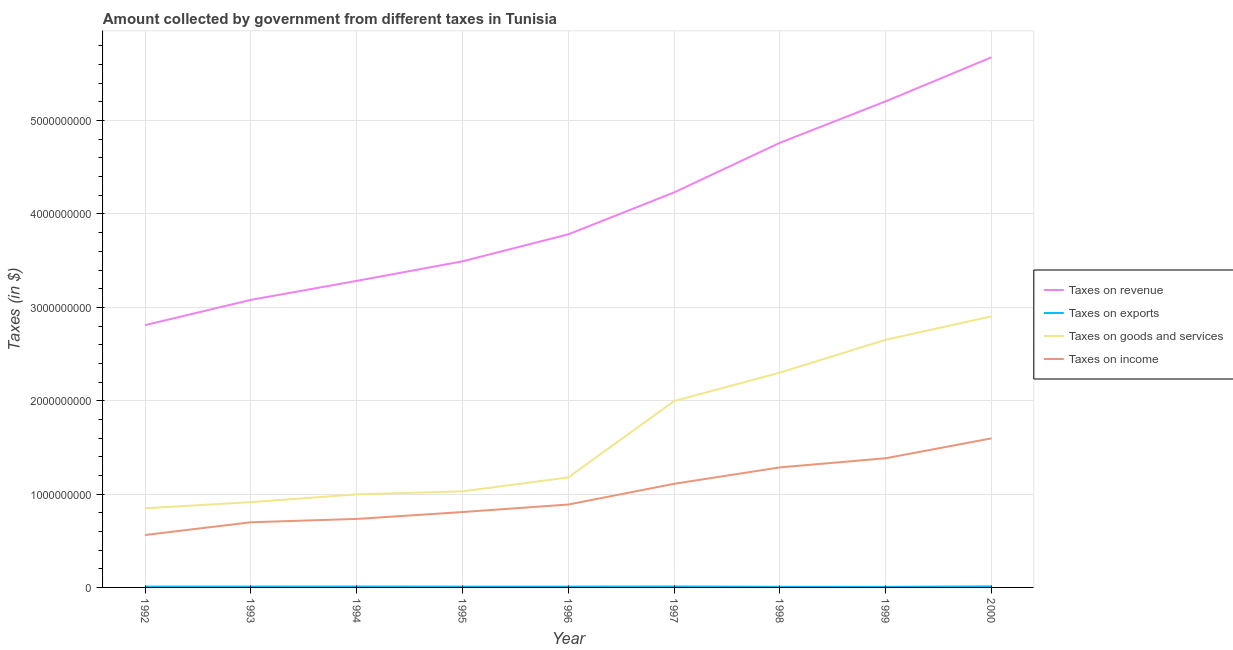Does the line corresponding to amount collected as tax on income intersect with the line corresponding to amount collected as tax on goods?
Your answer should be compact. No. What is the amount collected as tax on goods in 2000?
Your answer should be very brief. 2.90e+09. Across all years, what is the maximum amount collected as tax on income?
Provide a short and direct response. 1.60e+09. Across all years, what is the minimum amount collected as tax on exports?
Offer a very short reply. 6.20e+06. What is the total amount collected as tax on goods in the graph?
Give a very brief answer. 1.48e+1. What is the difference between the amount collected as tax on exports in 1995 and that in 2000?
Your answer should be very brief. -2.60e+06. What is the difference between the amount collected as tax on income in 1992 and the amount collected as tax on revenue in 1998?
Your response must be concise. -4.20e+09. What is the average amount collected as tax on exports per year?
Offer a terse response. 8.81e+06. In the year 1999, what is the difference between the amount collected as tax on exports and amount collected as tax on income?
Give a very brief answer. -1.38e+09. What is the ratio of the amount collected as tax on goods in 1993 to that in 1997?
Your response must be concise. 0.46. Is the difference between the amount collected as tax on revenue in 1992 and 1999 greater than the difference between the amount collected as tax on goods in 1992 and 1999?
Offer a terse response. No. What is the difference between the highest and the second highest amount collected as tax on goods?
Your answer should be very brief. 2.51e+08. What is the difference between the highest and the lowest amount collected as tax on income?
Ensure brevity in your answer.  1.04e+09. In how many years, is the amount collected as tax on revenue greater than the average amount collected as tax on revenue taken over all years?
Keep it short and to the point. 4. Is the sum of the amount collected as tax on revenue in 1992 and 1997 greater than the maximum amount collected as tax on income across all years?
Make the answer very short. Yes. Is it the case that in every year, the sum of the amount collected as tax on exports and amount collected as tax on goods is greater than the sum of amount collected as tax on revenue and amount collected as tax on income?
Provide a succinct answer. No. Is it the case that in every year, the sum of the amount collected as tax on revenue and amount collected as tax on exports is greater than the amount collected as tax on goods?
Keep it short and to the point. Yes. Does the amount collected as tax on exports monotonically increase over the years?
Your response must be concise. No. Is the amount collected as tax on income strictly greater than the amount collected as tax on revenue over the years?
Your response must be concise. No. Is the amount collected as tax on revenue strictly less than the amount collected as tax on income over the years?
Give a very brief answer. No. How many lines are there?
Your answer should be compact. 4. How many years are there in the graph?
Ensure brevity in your answer.  9. What is the difference between two consecutive major ticks on the Y-axis?
Offer a terse response. 1.00e+09. Does the graph contain any zero values?
Your answer should be very brief. No. Does the graph contain grids?
Your response must be concise. Yes. Where does the legend appear in the graph?
Provide a short and direct response. Center right. How many legend labels are there?
Offer a very short reply. 4. How are the legend labels stacked?
Your response must be concise. Vertical. What is the title of the graph?
Provide a short and direct response. Amount collected by government from different taxes in Tunisia. Does "Insurance services" appear as one of the legend labels in the graph?
Offer a terse response. No. What is the label or title of the Y-axis?
Offer a terse response. Taxes (in $). What is the Taxes (in $) in Taxes on revenue in 1992?
Give a very brief answer. 2.81e+09. What is the Taxes (in $) in Taxes on exports in 1992?
Your answer should be compact. 9.10e+06. What is the Taxes (in $) in Taxes on goods and services in 1992?
Give a very brief answer. 8.48e+08. What is the Taxes (in $) of Taxes on income in 1992?
Make the answer very short. 5.62e+08. What is the Taxes (in $) in Taxes on revenue in 1993?
Ensure brevity in your answer.  3.08e+09. What is the Taxes (in $) in Taxes on exports in 1993?
Offer a terse response. 9.10e+06. What is the Taxes (in $) in Taxes on goods and services in 1993?
Offer a terse response. 9.14e+08. What is the Taxes (in $) in Taxes on income in 1993?
Offer a very short reply. 6.98e+08. What is the Taxes (in $) of Taxes on revenue in 1994?
Provide a short and direct response. 3.28e+09. What is the Taxes (in $) of Taxes on exports in 1994?
Provide a succinct answer. 9.70e+06. What is the Taxes (in $) of Taxes on goods and services in 1994?
Offer a very short reply. 9.97e+08. What is the Taxes (in $) of Taxes on income in 1994?
Your answer should be compact. 7.34e+08. What is the Taxes (in $) of Taxes on revenue in 1995?
Ensure brevity in your answer.  3.49e+09. What is the Taxes (in $) of Taxes on exports in 1995?
Your answer should be compact. 8.60e+06. What is the Taxes (in $) in Taxes on goods and services in 1995?
Your answer should be very brief. 1.03e+09. What is the Taxes (in $) of Taxes on income in 1995?
Make the answer very short. 8.07e+08. What is the Taxes (in $) of Taxes on revenue in 1996?
Offer a very short reply. 3.78e+09. What is the Taxes (in $) of Taxes on exports in 1996?
Provide a short and direct response. 8.50e+06. What is the Taxes (in $) of Taxes on goods and services in 1996?
Provide a succinct answer. 1.18e+09. What is the Taxes (in $) of Taxes on income in 1996?
Give a very brief answer. 8.88e+08. What is the Taxes (in $) of Taxes on revenue in 1997?
Make the answer very short. 4.23e+09. What is the Taxes (in $) of Taxes on exports in 1997?
Offer a terse response. 1.02e+07. What is the Taxes (in $) in Taxes on goods and services in 1997?
Keep it short and to the point. 2.00e+09. What is the Taxes (in $) in Taxes on income in 1997?
Your answer should be compact. 1.11e+09. What is the Taxes (in $) in Taxes on revenue in 1998?
Your answer should be compact. 4.76e+09. What is the Taxes (in $) in Taxes on exports in 1998?
Give a very brief answer. 6.70e+06. What is the Taxes (in $) of Taxes on goods and services in 1998?
Keep it short and to the point. 2.30e+09. What is the Taxes (in $) in Taxes on income in 1998?
Your response must be concise. 1.29e+09. What is the Taxes (in $) in Taxes on revenue in 1999?
Provide a short and direct response. 5.21e+09. What is the Taxes (in $) in Taxes on exports in 1999?
Keep it short and to the point. 6.20e+06. What is the Taxes (in $) in Taxes on goods and services in 1999?
Offer a very short reply. 2.65e+09. What is the Taxes (in $) of Taxes on income in 1999?
Your response must be concise. 1.38e+09. What is the Taxes (in $) in Taxes on revenue in 2000?
Offer a terse response. 5.68e+09. What is the Taxes (in $) of Taxes on exports in 2000?
Make the answer very short. 1.12e+07. What is the Taxes (in $) of Taxes on goods and services in 2000?
Your response must be concise. 2.90e+09. What is the Taxes (in $) in Taxes on income in 2000?
Provide a succinct answer. 1.60e+09. Across all years, what is the maximum Taxes (in $) in Taxes on revenue?
Make the answer very short. 5.68e+09. Across all years, what is the maximum Taxes (in $) of Taxes on exports?
Give a very brief answer. 1.12e+07. Across all years, what is the maximum Taxes (in $) in Taxes on goods and services?
Offer a very short reply. 2.90e+09. Across all years, what is the maximum Taxes (in $) in Taxes on income?
Offer a very short reply. 1.60e+09. Across all years, what is the minimum Taxes (in $) of Taxes on revenue?
Your answer should be very brief. 2.81e+09. Across all years, what is the minimum Taxes (in $) of Taxes on exports?
Keep it short and to the point. 6.20e+06. Across all years, what is the minimum Taxes (in $) of Taxes on goods and services?
Make the answer very short. 8.48e+08. Across all years, what is the minimum Taxes (in $) of Taxes on income?
Your answer should be very brief. 5.62e+08. What is the total Taxes (in $) in Taxes on revenue in the graph?
Ensure brevity in your answer.  3.63e+1. What is the total Taxes (in $) in Taxes on exports in the graph?
Your answer should be very brief. 7.93e+07. What is the total Taxes (in $) in Taxes on goods and services in the graph?
Give a very brief answer. 1.48e+1. What is the total Taxes (in $) of Taxes on income in the graph?
Offer a very short reply. 9.07e+09. What is the difference between the Taxes (in $) of Taxes on revenue in 1992 and that in 1993?
Make the answer very short. -2.71e+08. What is the difference between the Taxes (in $) of Taxes on exports in 1992 and that in 1993?
Provide a short and direct response. 0. What is the difference between the Taxes (in $) of Taxes on goods and services in 1992 and that in 1993?
Make the answer very short. -6.58e+07. What is the difference between the Taxes (in $) of Taxes on income in 1992 and that in 1993?
Provide a short and direct response. -1.36e+08. What is the difference between the Taxes (in $) in Taxes on revenue in 1992 and that in 1994?
Your answer should be compact. -4.74e+08. What is the difference between the Taxes (in $) in Taxes on exports in 1992 and that in 1994?
Keep it short and to the point. -6.00e+05. What is the difference between the Taxes (in $) of Taxes on goods and services in 1992 and that in 1994?
Give a very brief answer. -1.49e+08. What is the difference between the Taxes (in $) of Taxes on income in 1992 and that in 1994?
Your answer should be compact. -1.72e+08. What is the difference between the Taxes (in $) of Taxes on revenue in 1992 and that in 1995?
Provide a short and direct response. -6.84e+08. What is the difference between the Taxes (in $) of Taxes on exports in 1992 and that in 1995?
Offer a very short reply. 5.00e+05. What is the difference between the Taxes (in $) in Taxes on goods and services in 1992 and that in 1995?
Offer a terse response. -1.82e+08. What is the difference between the Taxes (in $) of Taxes on income in 1992 and that in 1995?
Your answer should be very brief. -2.46e+08. What is the difference between the Taxes (in $) of Taxes on revenue in 1992 and that in 1996?
Your response must be concise. -9.73e+08. What is the difference between the Taxes (in $) in Taxes on goods and services in 1992 and that in 1996?
Ensure brevity in your answer.  -3.31e+08. What is the difference between the Taxes (in $) in Taxes on income in 1992 and that in 1996?
Give a very brief answer. -3.27e+08. What is the difference between the Taxes (in $) of Taxes on revenue in 1992 and that in 1997?
Your answer should be compact. -1.42e+09. What is the difference between the Taxes (in $) in Taxes on exports in 1992 and that in 1997?
Offer a very short reply. -1.10e+06. What is the difference between the Taxes (in $) in Taxes on goods and services in 1992 and that in 1997?
Keep it short and to the point. -1.15e+09. What is the difference between the Taxes (in $) of Taxes on income in 1992 and that in 1997?
Provide a succinct answer. -5.48e+08. What is the difference between the Taxes (in $) of Taxes on revenue in 1992 and that in 1998?
Offer a very short reply. -1.95e+09. What is the difference between the Taxes (in $) of Taxes on exports in 1992 and that in 1998?
Keep it short and to the point. 2.40e+06. What is the difference between the Taxes (in $) of Taxes on goods and services in 1992 and that in 1998?
Offer a terse response. -1.45e+09. What is the difference between the Taxes (in $) of Taxes on income in 1992 and that in 1998?
Your answer should be compact. -7.24e+08. What is the difference between the Taxes (in $) in Taxes on revenue in 1992 and that in 1999?
Offer a terse response. -2.40e+09. What is the difference between the Taxes (in $) in Taxes on exports in 1992 and that in 1999?
Give a very brief answer. 2.90e+06. What is the difference between the Taxes (in $) of Taxes on goods and services in 1992 and that in 1999?
Keep it short and to the point. -1.81e+09. What is the difference between the Taxes (in $) in Taxes on income in 1992 and that in 1999?
Your answer should be very brief. -8.22e+08. What is the difference between the Taxes (in $) of Taxes on revenue in 1992 and that in 2000?
Offer a terse response. -2.87e+09. What is the difference between the Taxes (in $) in Taxes on exports in 1992 and that in 2000?
Keep it short and to the point. -2.10e+06. What is the difference between the Taxes (in $) in Taxes on goods and services in 1992 and that in 2000?
Ensure brevity in your answer.  -2.06e+09. What is the difference between the Taxes (in $) in Taxes on income in 1992 and that in 2000?
Offer a very short reply. -1.04e+09. What is the difference between the Taxes (in $) in Taxes on revenue in 1993 and that in 1994?
Keep it short and to the point. -2.03e+08. What is the difference between the Taxes (in $) of Taxes on exports in 1993 and that in 1994?
Keep it short and to the point. -6.00e+05. What is the difference between the Taxes (in $) in Taxes on goods and services in 1993 and that in 1994?
Keep it short and to the point. -8.32e+07. What is the difference between the Taxes (in $) of Taxes on income in 1993 and that in 1994?
Keep it short and to the point. -3.57e+07. What is the difference between the Taxes (in $) of Taxes on revenue in 1993 and that in 1995?
Your answer should be compact. -4.13e+08. What is the difference between the Taxes (in $) in Taxes on exports in 1993 and that in 1995?
Keep it short and to the point. 5.00e+05. What is the difference between the Taxes (in $) in Taxes on goods and services in 1993 and that in 1995?
Your answer should be very brief. -1.16e+08. What is the difference between the Taxes (in $) of Taxes on income in 1993 and that in 1995?
Make the answer very short. -1.09e+08. What is the difference between the Taxes (in $) in Taxes on revenue in 1993 and that in 1996?
Offer a terse response. -7.02e+08. What is the difference between the Taxes (in $) in Taxes on goods and services in 1993 and that in 1996?
Provide a succinct answer. -2.65e+08. What is the difference between the Taxes (in $) in Taxes on income in 1993 and that in 1996?
Provide a short and direct response. -1.90e+08. What is the difference between the Taxes (in $) of Taxes on revenue in 1993 and that in 1997?
Keep it short and to the point. -1.15e+09. What is the difference between the Taxes (in $) in Taxes on exports in 1993 and that in 1997?
Your answer should be compact. -1.10e+06. What is the difference between the Taxes (in $) in Taxes on goods and services in 1993 and that in 1997?
Offer a terse response. -1.08e+09. What is the difference between the Taxes (in $) in Taxes on income in 1993 and that in 1997?
Keep it short and to the point. -4.12e+08. What is the difference between the Taxes (in $) in Taxes on revenue in 1993 and that in 1998?
Keep it short and to the point. -1.68e+09. What is the difference between the Taxes (in $) in Taxes on exports in 1993 and that in 1998?
Your answer should be compact. 2.40e+06. What is the difference between the Taxes (in $) of Taxes on goods and services in 1993 and that in 1998?
Offer a terse response. -1.39e+09. What is the difference between the Taxes (in $) in Taxes on income in 1993 and that in 1998?
Give a very brief answer. -5.88e+08. What is the difference between the Taxes (in $) in Taxes on revenue in 1993 and that in 1999?
Provide a succinct answer. -2.13e+09. What is the difference between the Taxes (in $) in Taxes on exports in 1993 and that in 1999?
Give a very brief answer. 2.90e+06. What is the difference between the Taxes (in $) of Taxes on goods and services in 1993 and that in 1999?
Ensure brevity in your answer.  -1.74e+09. What is the difference between the Taxes (in $) of Taxes on income in 1993 and that in 1999?
Your answer should be compact. -6.86e+08. What is the difference between the Taxes (in $) in Taxes on revenue in 1993 and that in 2000?
Offer a very short reply. -2.60e+09. What is the difference between the Taxes (in $) of Taxes on exports in 1993 and that in 2000?
Provide a succinct answer. -2.10e+06. What is the difference between the Taxes (in $) of Taxes on goods and services in 1993 and that in 2000?
Provide a succinct answer. -1.99e+09. What is the difference between the Taxes (in $) in Taxes on income in 1993 and that in 2000?
Your answer should be compact. -8.99e+08. What is the difference between the Taxes (in $) of Taxes on revenue in 1994 and that in 1995?
Ensure brevity in your answer.  -2.10e+08. What is the difference between the Taxes (in $) in Taxes on exports in 1994 and that in 1995?
Offer a very short reply. 1.10e+06. What is the difference between the Taxes (in $) in Taxes on goods and services in 1994 and that in 1995?
Your response must be concise. -3.26e+07. What is the difference between the Taxes (in $) of Taxes on income in 1994 and that in 1995?
Your response must be concise. -7.36e+07. What is the difference between the Taxes (in $) in Taxes on revenue in 1994 and that in 1996?
Your answer should be compact. -4.99e+08. What is the difference between the Taxes (in $) of Taxes on exports in 1994 and that in 1996?
Your answer should be very brief. 1.20e+06. What is the difference between the Taxes (in $) in Taxes on goods and services in 1994 and that in 1996?
Provide a succinct answer. -1.82e+08. What is the difference between the Taxes (in $) in Taxes on income in 1994 and that in 1996?
Ensure brevity in your answer.  -1.54e+08. What is the difference between the Taxes (in $) in Taxes on revenue in 1994 and that in 1997?
Ensure brevity in your answer.  -9.47e+08. What is the difference between the Taxes (in $) of Taxes on exports in 1994 and that in 1997?
Make the answer very short. -5.00e+05. What is the difference between the Taxes (in $) in Taxes on goods and services in 1994 and that in 1997?
Provide a succinct answer. -1.00e+09. What is the difference between the Taxes (in $) of Taxes on income in 1994 and that in 1997?
Ensure brevity in your answer.  -3.76e+08. What is the difference between the Taxes (in $) in Taxes on revenue in 1994 and that in 1998?
Keep it short and to the point. -1.48e+09. What is the difference between the Taxes (in $) in Taxes on goods and services in 1994 and that in 1998?
Keep it short and to the point. -1.30e+09. What is the difference between the Taxes (in $) of Taxes on income in 1994 and that in 1998?
Provide a succinct answer. -5.52e+08. What is the difference between the Taxes (in $) in Taxes on revenue in 1994 and that in 1999?
Your response must be concise. -1.92e+09. What is the difference between the Taxes (in $) in Taxes on exports in 1994 and that in 1999?
Give a very brief answer. 3.50e+06. What is the difference between the Taxes (in $) in Taxes on goods and services in 1994 and that in 1999?
Offer a terse response. -1.66e+09. What is the difference between the Taxes (in $) of Taxes on income in 1994 and that in 1999?
Keep it short and to the point. -6.50e+08. What is the difference between the Taxes (in $) of Taxes on revenue in 1994 and that in 2000?
Offer a terse response. -2.39e+09. What is the difference between the Taxes (in $) in Taxes on exports in 1994 and that in 2000?
Make the answer very short. -1.50e+06. What is the difference between the Taxes (in $) in Taxes on goods and services in 1994 and that in 2000?
Provide a succinct answer. -1.91e+09. What is the difference between the Taxes (in $) in Taxes on income in 1994 and that in 2000?
Offer a terse response. -8.63e+08. What is the difference between the Taxes (in $) in Taxes on revenue in 1995 and that in 1996?
Keep it short and to the point. -2.89e+08. What is the difference between the Taxes (in $) of Taxes on goods and services in 1995 and that in 1996?
Make the answer very short. -1.49e+08. What is the difference between the Taxes (in $) of Taxes on income in 1995 and that in 1996?
Make the answer very short. -8.08e+07. What is the difference between the Taxes (in $) of Taxes on revenue in 1995 and that in 1997?
Your answer should be very brief. -7.38e+08. What is the difference between the Taxes (in $) of Taxes on exports in 1995 and that in 1997?
Your answer should be very brief. -1.60e+06. What is the difference between the Taxes (in $) in Taxes on goods and services in 1995 and that in 1997?
Ensure brevity in your answer.  -9.67e+08. What is the difference between the Taxes (in $) in Taxes on income in 1995 and that in 1997?
Offer a very short reply. -3.02e+08. What is the difference between the Taxes (in $) in Taxes on revenue in 1995 and that in 1998?
Provide a short and direct response. -1.27e+09. What is the difference between the Taxes (in $) in Taxes on exports in 1995 and that in 1998?
Keep it short and to the point. 1.90e+06. What is the difference between the Taxes (in $) of Taxes on goods and services in 1995 and that in 1998?
Give a very brief answer. -1.27e+09. What is the difference between the Taxes (in $) of Taxes on income in 1995 and that in 1998?
Keep it short and to the point. -4.78e+08. What is the difference between the Taxes (in $) of Taxes on revenue in 1995 and that in 1999?
Your answer should be very brief. -1.71e+09. What is the difference between the Taxes (in $) in Taxes on exports in 1995 and that in 1999?
Offer a very short reply. 2.40e+06. What is the difference between the Taxes (in $) in Taxes on goods and services in 1995 and that in 1999?
Offer a very short reply. -1.62e+09. What is the difference between the Taxes (in $) in Taxes on income in 1995 and that in 1999?
Keep it short and to the point. -5.76e+08. What is the difference between the Taxes (in $) in Taxes on revenue in 1995 and that in 2000?
Your answer should be very brief. -2.19e+09. What is the difference between the Taxes (in $) in Taxes on exports in 1995 and that in 2000?
Provide a short and direct response. -2.60e+06. What is the difference between the Taxes (in $) of Taxes on goods and services in 1995 and that in 2000?
Your answer should be compact. -1.87e+09. What is the difference between the Taxes (in $) in Taxes on income in 1995 and that in 2000?
Ensure brevity in your answer.  -7.89e+08. What is the difference between the Taxes (in $) of Taxes on revenue in 1996 and that in 1997?
Your answer should be compact. -4.49e+08. What is the difference between the Taxes (in $) in Taxes on exports in 1996 and that in 1997?
Make the answer very short. -1.70e+06. What is the difference between the Taxes (in $) in Taxes on goods and services in 1996 and that in 1997?
Your answer should be compact. -8.18e+08. What is the difference between the Taxes (in $) in Taxes on income in 1996 and that in 1997?
Your answer should be very brief. -2.22e+08. What is the difference between the Taxes (in $) of Taxes on revenue in 1996 and that in 1998?
Offer a terse response. -9.80e+08. What is the difference between the Taxes (in $) of Taxes on exports in 1996 and that in 1998?
Make the answer very short. 1.80e+06. What is the difference between the Taxes (in $) of Taxes on goods and services in 1996 and that in 1998?
Provide a succinct answer. -1.12e+09. What is the difference between the Taxes (in $) of Taxes on income in 1996 and that in 1998?
Your response must be concise. -3.98e+08. What is the difference between the Taxes (in $) in Taxes on revenue in 1996 and that in 1999?
Your response must be concise. -1.42e+09. What is the difference between the Taxes (in $) of Taxes on exports in 1996 and that in 1999?
Offer a very short reply. 2.30e+06. What is the difference between the Taxes (in $) of Taxes on goods and services in 1996 and that in 1999?
Make the answer very short. -1.47e+09. What is the difference between the Taxes (in $) of Taxes on income in 1996 and that in 1999?
Provide a short and direct response. -4.96e+08. What is the difference between the Taxes (in $) in Taxes on revenue in 1996 and that in 2000?
Offer a terse response. -1.90e+09. What is the difference between the Taxes (in $) of Taxes on exports in 1996 and that in 2000?
Offer a very short reply. -2.70e+06. What is the difference between the Taxes (in $) of Taxes on goods and services in 1996 and that in 2000?
Make the answer very short. -1.73e+09. What is the difference between the Taxes (in $) of Taxes on income in 1996 and that in 2000?
Provide a short and direct response. -7.09e+08. What is the difference between the Taxes (in $) of Taxes on revenue in 1997 and that in 1998?
Your answer should be compact. -5.32e+08. What is the difference between the Taxes (in $) in Taxes on exports in 1997 and that in 1998?
Your answer should be very brief. 3.50e+06. What is the difference between the Taxes (in $) of Taxes on goods and services in 1997 and that in 1998?
Offer a very short reply. -3.04e+08. What is the difference between the Taxes (in $) in Taxes on income in 1997 and that in 1998?
Give a very brief answer. -1.76e+08. What is the difference between the Taxes (in $) in Taxes on revenue in 1997 and that in 1999?
Your answer should be very brief. -9.76e+08. What is the difference between the Taxes (in $) of Taxes on exports in 1997 and that in 1999?
Your response must be concise. 4.00e+06. What is the difference between the Taxes (in $) of Taxes on goods and services in 1997 and that in 1999?
Make the answer very short. -6.56e+08. What is the difference between the Taxes (in $) in Taxes on income in 1997 and that in 1999?
Provide a short and direct response. -2.74e+08. What is the difference between the Taxes (in $) of Taxes on revenue in 1997 and that in 2000?
Provide a short and direct response. -1.45e+09. What is the difference between the Taxes (in $) in Taxes on goods and services in 1997 and that in 2000?
Offer a terse response. -9.07e+08. What is the difference between the Taxes (in $) in Taxes on income in 1997 and that in 2000?
Your answer should be compact. -4.87e+08. What is the difference between the Taxes (in $) of Taxes on revenue in 1998 and that in 1999?
Your answer should be compact. -4.44e+08. What is the difference between the Taxes (in $) of Taxes on exports in 1998 and that in 1999?
Ensure brevity in your answer.  5.00e+05. What is the difference between the Taxes (in $) in Taxes on goods and services in 1998 and that in 1999?
Your answer should be compact. -3.52e+08. What is the difference between the Taxes (in $) of Taxes on income in 1998 and that in 1999?
Offer a very short reply. -9.78e+07. What is the difference between the Taxes (in $) of Taxes on revenue in 1998 and that in 2000?
Your answer should be compact. -9.16e+08. What is the difference between the Taxes (in $) in Taxes on exports in 1998 and that in 2000?
Keep it short and to the point. -4.50e+06. What is the difference between the Taxes (in $) of Taxes on goods and services in 1998 and that in 2000?
Provide a succinct answer. -6.03e+08. What is the difference between the Taxes (in $) of Taxes on income in 1998 and that in 2000?
Your answer should be compact. -3.11e+08. What is the difference between the Taxes (in $) in Taxes on revenue in 1999 and that in 2000?
Your answer should be compact. -4.72e+08. What is the difference between the Taxes (in $) of Taxes on exports in 1999 and that in 2000?
Your response must be concise. -5.00e+06. What is the difference between the Taxes (in $) of Taxes on goods and services in 1999 and that in 2000?
Ensure brevity in your answer.  -2.51e+08. What is the difference between the Taxes (in $) of Taxes on income in 1999 and that in 2000?
Make the answer very short. -2.13e+08. What is the difference between the Taxes (in $) in Taxes on revenue in 1992 and the Taxes (in $) in Taxes on exports in 1993?
Your answer should be very brief. 2.80e+09. What is the difference between the Taxes (in $) in Taxes on revenue in 1992 and the Taxes (in $) in Taxes on goods and services in 1993?
Keep it short and to the point. 1.90e+09. What is the difference between the Taxes (in $) in Taxes on revenue in 1992 and the Taxes (in $) in Taxes on income in 1993?
Your answer should be very brief. 2.11e+09. What is the difference between the Taxes (in $) in Taxes on exports in 1992 and the Taxes (in $) in Taxes on goods and services in 1993?
Your answer should be compact. -9.04e+08. What is the difference between the Taxes (in $) of Taxes on exports in 1992 and the Taxes (in $) of Taxes on income in 1993?
Your response must be concise. -6.89e+08. What is the difference between the Taxes (in $) in Taxes on goods and services in 1992 and the Taxes (in $) in Taxes on income in 1993?
Provide a short and direct response. 1.50e+08. What is the difference between the Taxes (in $) in Taxes on revenue in 1992 and the Taxes (in $) in Taxes on exports in 1994?
Your answer should be compact. 2.80e+09. What is the difference between the Taxes (in $) in Taxes on revenue in 1992 and the Taxes (in $) in Taxes on goods and services in 1994?
Give a very brief answer. 1.81e+09. What is the difference between the Taxes (in $) in Taxes on revenue in 1992 and the Taxes (in $) in Taxes on income in 1994?
Your answer should be compact. 2.08e+09. What is the difference between the Taxes (in $) of Taxes on exports in 1992 and the Taxes (in $) of Taxes on goods and services in 1994?
Your response must be concise. -9.88e+08. What is the difference between the Taxes (in $) of Taxes on exports in 1992 and the Taxes (in $) of Taxes on income in 1994?
Your answer should be compact. -7.25e+08. What is the difference between the Taxes (in $) in Taxes on goods and services in 1992 and the Taxes (in $) in Taxes on income in 1994?
Your answer should be compact. 1.14e+08. What is the difference between the Taxes (in $) in Taxes on revenue in 1992 and the Taxes (in $) in Taxes on exports in 1995?
Keep it short and to the point. 2.80e+09. What is the difference between the Taxes (in $) of Taxes on revenue in 1992 and the Taxes (in $) of Taxes on goods and services in 1995?
Give a very brief answer. 1.78e+09. What is the difference between the Taxes (in $) in Taxes on revenue in 1992 and the Taxes (in $) in Taxes on income in 1995?
Make the answer very short. 2.00e+09. What is the difference between the Taxes (in $) in Taxes on exports in 1992 and the Taxes (in $) in Taxes on goods and services in 1995?
Ensure brevity in your answer.  -1.02e+09. What is the difference between the Taxes (in $) in Taxes on exports in 1992 and the Taxes (in $) in Taxes on income in 1995?
Give a very brief answer. -7.98e+08. What is the difference between the Taxes (in $) of Taxes on goods and services in 1992 and the Taxes (in $) of Taxes on income in 1995?
Provide a short and direct response. 4.03e+07. What is the difference between the Taxes (in $) in Taxes on revenue in 1992 and the Taxes (in $) in Taxes on exports in 1996?
Offer a terse response. 2.80e+09. What is the difference between the Taxes (in $) of Taxes on revenue in 1992 and the Taxes (in $) of Taxes on goods and services in 1996?
Give a very brief answer. 1.63e+09. What is the difference between the Taxes (in $) of Taxes on revenue in 1992 and the Taxes (in $) of Taxes on income in 1996?
Provide a short and direct response. 1.92e+09. What is the difference between the Taxes (in $) of Taxes on exports in 1992 and the Taxes (in $) of Taxes on goods and services in 1996?
Give a very brief answer. -1.17e+09. What is the difference between the Taxes (in $) of Taxes on exports in 1992 and the Taxes (in $) of Taxes on income in 1996?
Your answer should be compact. -8.79e+08. What is the difference between the Taxes (in $) of Taxes on goods and services in 1992 and the Taxes (in $) of Taxes on income in 1996?
Keep it short and to the point. -4.05e+07. What is the difference between the Taxes (in $) of Taxes on revenue in 1992 and the Taxes (in $) of Taxes on exports in 1997?
Your answer should be compact. 2.80e+09. What is the difference between the Taxes (in $) of Taxes on revenue in 1992 and the Taxes (in $) of Taxes on goods and services in 1997?
Provide a short and direct response. 8.13e+08. What is the difference between the Taxes (in $) of Taxes on revenue in 1992 and the Taxes (in $) of Taxes on income in 1997?
Your answer should be compact. 1.70e+09. What is the difference between the Taxes (in $) in Taxes on exports in 1992 and the Taxes (in $) in Taxes on goods and services in 1997?
Your answer should be compact. -1.99e+09. What is the difference between the Taxes (in $) of Taxes on exports in 1992 and the Taxes (in $) of Taxes on income in 1997?
Offer a very short reply. -1.10e+09. What is the difference between the Taxes (in $) of Taxes on goods and services in 1992 and the Taxes (in $) of Taxes on income in 1997?
Make the answer very short. -2.62e+08. What is the difference between the Taxes (in $) in Taxes on revenue in 1992 and the Taxes (in $) in Taxes on exports in 1998?
Your answer should be very brief. 2.80e+09. What is the difference between the Taxes (in $) of Taxes on revenue in 1992 and the Taxes (in $) of Taxes on goods and services in 1998?
Provide a short and direct response. 5.09e+08. What is the difference between the Taxes (in $) in Taxes on revenue in 1992 and the Taxes (in $) in Taxes on income in 1998?
Offer a very short reply. 1.52e+09. What is the difference between the Taxes (in $) of Taxes on exports in 1992 and the Taxes (in $) of Taxes on goods and services in 1998?
Your answer should be compact. -2.29e+09. What is the difference between the Taxes (in $) in Taxes on exports in 1992 and the Taxes (in $) in Taxes on income in 1998?
Your answer should be very brief. -1.28e+09. What is the difference between the Taxes (in $) of Taxes on goods and services in 1992 and the Taxes (in $) of Taxes on income in 1998?
Your response must be concise. -4.38e+08. What is the difference between the Taxes (in $) of Taxes on revenue in 1992 and the Taxes (in $) of Taxes on exports in 1999?
Your answer should be very brief. 2.80e+09. What is the difference between the Taxes (in $) in Taxes on revenue in 1992 and the Taxes (in $) in Taxes on goods and services in 1999?
Provide a succinct answer. 1.57e+08. What is the difference between the Taxes (in $) of Taxes on revenue in 1992 and the Taxes (in $) of Taxes on income in 1999?
Make the answer very short. 1.43e+09. What is the difference between the Taxes (in $) of Taxes on exports in 1992 and the Taxes (in $) of Taxes on goods and services in 1999?
Provide a short and direct response. -2.64e+09. What is the difference between the Taxes (in $) in Taxes on exports in 1992 and the Taxes (in $) in Taxes on income in 1999?
Offer a very short reply. -1.37e+09. What is the difference between the Taxes (in $) of Taxes on goods and services in 1992 and the Taxes (in $) of Taxes on income in 1999?
Your response must be concise. -5.36e+08. What is the difference between the Taxes (in $) in Taxes on revenue in 1992 and the Taxes (in $) in Taxes on exports in 2000?
Give a very brief answer. 2.80e+09. What is the difference between the Taxes (in $) of Taxes on revenue in 1992 and the Taxes (in $) of Taxes on goods and services in 2000?
Offer a very short reply. -9.40e+07. What is the difference between the Taxes (in $) in Taxes on revenue in 1992 and the Taxes (in $) in Taxes on income in 2000?
Your answer should be compact. 1.21e+09. What is the difference between the Taxes (in $) of Taxes on exports in 1992 and the Taxes (in $) of Taxes on goods and services in 2000?
Give a very brief answer. -2.89e+09. What is the difference between the Taxes (in $) in Taxes on exports in 1992 and the Taxes (in $) in Taxes on income in 2000?
Your response must be concise. -1.59e+09. What is the difference between the Taxes (in $) in Taxes on goods and services in 1992 and the Taxes (in $) in Taxes on income in 2000?
Provide a short and direct response. -7.49e+08. What is the difference between the Taxes (in $) of Taxes on revenue in 1993 and the Taxes (in $) of Taxes on exports in 1994?
Ensure brevity in your answer.  3.07e+09. What is the difference between the Taxes (in $) of Taxes on revenue in 1993 and the Taxes (in $) of Taxes on goods and services in 1994?
Your response must be concise. 2.08e+09. What is the difference between the Taxes (in $) in Taxes on revenue in 1993 and the Taxes (in $) in Taxes on income in 1994?
Offer a very short reply. 2.35e+09. What is the difference between the Taxes (in $) in Taxes on exports in 1993 and the Taxes (in $) in Taxes on goods and services in 1994?
Your response must be concise. -9.88e+08. What is the difference between the Taxes (in $) of Taxes on exports in 1993 and the Taxes (in $) of Taxes on income in 1994?
Offer a very short reply. -7.25e+08. What is the difference between the Taxes (in $) of Taxes on goods and services in 1993 and the Taxes (in $) of Taxes on income in 1994?
Make the answer very short. 1.80e+08. What is the difference between the Taxes (in $) of Taxes on revenue in 1993 and the Taxes (in $) of Taxes on exports in 1995?
Your response must be concise. 3.07e+09. What is the difference between the Taxes (in $) of Taxes on revenue in 1993 and the Taxes (in $) of Taxes on goods and services in 1995?
Offer a very short reply. 2.05e+09. What is the difference between the Taxes (in $) of Taxes on revenue in 1993 and the Taxes (in $) of Taxes on income in 1995?
Offer a very short reply. 2.27e+09. What is the difference between the Taxes (in $) in Taxes on exports in 1993 and the Taxes (in $) in Taxes on goods and services in 1995?
Provide a succinct answer. -1.02e+09. What is the difference between the Taxes (in $) of Taxes on exports in 1993 and the Taxes (in $) of Taxes on income in 1995?
Give a very brief answer. -7.98e+08. What is the difference between the Taxes (in $) in Taxes on goods and services in 1993 and the Taxes (in $) in Taxes on income in 1995?
Keep it short and to the point. 1.06e+08. What is the difference between the Taxes (in $) of Taxes on revenue in 1993 and the Taxes (in $) of Taxes on exports in 1996?
Your response must be concise. 3.07e+09. What is the difference between the Taxes (in $) in Taxes on revenue in 1993 and the Taxes (in $) in Taxes on goods and services in 1996?
Your answer should be compact. 1.90e+09. What is the difference between the Taxes (in $) of Taxes on revenue in 1993 and the Taxes (in $) of Taxes on income in 1996?
Your response must be concise. 2.19e+09. What is the difference between the Taxes (in $) in Taxes on exports in 1993 and the Taxes (in $) in Taxes on goods and services in 1996?
Provide a succinct answer. -1.17e+09. What is the difference between the Taxes (in $) in Taxes on exports in 1993 and the Taxes (in $) in Taxes on income in 1996?
Provide a succinct answer. -8.79e+08. What is the difference between the Taxes (in $) of Taxes on goods and services in 1993 and the Taxes (in $) of Taxes on income in 1996?
Your answer should be very brief. 2.53e+07. What is the difference between the Taxes (in $) in Taxes on revenue in 1993 and the Taxes (in $) in Taxes on exports in 1997?
Your answer should be compact. 3.07e+09. What is the difference between the Taxes (in $) in Taxes on revenue in 1993 and the Taxes (in $) in Taxes on goods and services in 1997?
Offer a very short reply. 1.08e+09. What is the difference between the Taxes (in $) of Taxes on revenue in 1993 and the Taxes (in $) of Taxes on income in 1997?
Give a very brief answer. 1.97e+09. What is the difference between the Taxes (in $) of Taxes on exports in 1993 and the Taxes (in $) of Taxes on goods and services in 1997?
Make the answer very short. -1.99e+09. What is the difference between the Taxes (in $) of Taxes on exports in 1993 and the Taxes (in $) of Taxes on income in 1997?
Provide a short and direct response. -1.10e+09. What is the difference between the Taxes (in $) of Taxes on goods and services in 1993 and the Taxes (in $) of Taxes on income in 1997?
Your answer should be very brief. -1.96e+08. What is the difference between the Taxes (in $) in Taxes on revenue in 1993 and the Taxes (in $) in Taxes on exports in 1998?
Give a very brief answer. 3.07e+09. What is the difference between the Taxes (in $) in Taxes on revenue in 1993 and the Taxes (in $) in Taxes on goods and services in 1998?
Ensure brevity in your answer.  7.80e+08. What is the difference between the Taxes (in $) in Taxes on revenue in 1993 and the Taxes (in $) in Taxes on income in 1998?
Make the answer very short. 1.79e+09. What is the difference between the Taxes (in $) of Taxes on exports in 1993 and the Taxes (in $) of Taxes on goods and services in 1998?
Offer a very short reply. -2.29e+09. What is the difference between the Taxes (in $) in Taxes on exports in 1993 and the Taxes (in $) in Taxes on income in 1998?
Your response must be concise. -1.28e+09. What is the difference between the Taxes (in $) in Taxes on goods and services in 1993 and the Taxes (in $) in Taxes on income in 1998?
Give a very brief answer. -3.72e+08. What is the difference between the Taxes (in $) in Taxes on revenue in 1993 and the Taxes (in $) in Taxes on exports in 1999?
Your response must be concise. 3.07e+09. What is the difference between the Taxes (in $) of Taxes on revenue in 1993 and the Taxes (in $) of Taxes on goods and services in 1999?
Keep it short and to the point. 4.28e+08. What is the difference between the Taxes (in $) in Taxes on revenue in 1993 and the Taxes (in $) in Taxes on income in 1999?
Make the answer very short. 1.70e+09. What is the difference between the Taxes (in $) in Taxes on exports in 1993 and the Taxes (in $) in Taxes on goods and services in 1999?
Your response must be concise. -2.64e+09. What is the difference between the Taxes (in $) of Taxes on exports in 1993 and the Taxes (in $) of Taxes on income in 1999?
Give a very brief answer. -1.37e+09. What is the difference between the Taxes (in $) of Taxes on goods and services in 1993 and the Taxes (in $) of Taxes on income in 1999?
Provide a short and direct response. -4.70e+08. What is the difference between the Taxes (in $) of Taxes on revenue in 1993 and the Taxes (in $) of Taxes on exports in 2000?
Give a very brief answer. 3.07e+09. What is the difference between the Taxes (in $) in Taxes on revenue in 1993 and the Taxes (in $) in Taxes on goods and services in 2000?
Provide a succinct answer. 1.77e+08. What is the difference between the Taxes (in $) of Taxes on revenue in 1993 and the Taxes (in $) of Taxes on income in 2000?
Make the answer very short. 1.48e+09. What is the difference between the Taxes (in $) of Taxes on exports in 1993 and the Taxes (in $) of Taxes on goods and services in 2000?
Keep it short and to the point. -2.89e+09. What is the difference between the Taxes (in $) in Taxes on exports in 1993 and the Taxes (in $) in Taxes on income in 2000?
Make the answer very short. -1.59e+09. What is the difference between the Taxes (in $) in Taxes on goods and services in 1993 and the Taxes (in $) in Taxes on income in 2000?
Your response must be concise. -6.83e+08. What is the difference between the Taxes (in $) of Taxes on revenue in 1994 and the Taxes (in $) of Taxes on exports in 1995?
Offer a terse response. 3.28e+09. What is the difference between the Taxes (in $) in Taxes on revenue in 1994 and the Taxes (in $) in Taxes on goods and services in 1995?
Provide a short and direct response. 2.25e+09. What is the difference between the Taxes (in $) in Taxes on revenue in 1994 and the Taxes (in $) in Taxes on income in 1995?
Offer a terse response. 2.48e+09. What is the difference between the Taxes (in $) of Taxes on exports in 1994 and the Taxes (in $) of Taxes on goods and services in 1995?
Ensure brevity in your answer.  -1.02e+09. What is the difference between the Taxes (in $) in Taxes on exports in 1994 and the Taxes (in $) in Taxes on income in 1995?
Ensure brevity in your answer.  -7.98e+08. What is the difference between the Taxes (in $) of Taxes on goods and services in 1994 and the Taxes (in $) of Taxes on income in 1995?
Offer a terse response. 1.89e+08. What is the difference between the Taxes (in $) in Taxes on revenue in 1994 and the Taxes (in $) in Taxes on exports in 1996?
Your response must be concise. 3.28e+09. What is the difference between the Taxes (in $) in Taxes on revenue in 1994 and the Taxes (in $) in Taxes on goods and services in 1996?
Your answer should be very brief. 2.11e+09. What is the difference between the Taxes (in $) in Taxes on revenue in 1994 and the Taxes (in $) in Taxes on income in 1996?
Your response must be concise. 2.40e+09. What is the difference between the Taxes (in $) of Taxes on exports in 1994 and the Taxes (in $) of Taxes on goods and services in 1996?
Offer a terse response. -1.17e+09. What is the difference between the Taxes (in $) in Taxes on exports in 1994 and the Taxes (in $) in Taxes on income in 1996?
Ensure brevity in your answer.  -8.78e+08. What is the difference between the Taxes (in $) in Taxes on goods and services in 1994 and the Taxes (in $) in Taxes on income in 1996?
Offer a very short reply. 1.08e+08. What is the difference between the Taxes (in $) of Taxes on revenue in 1994 and the Taxes (in $) of Taxes on exports in 1997?
Offer a very short reply. 3.27e+09. What is the difference between the Taxes (in $) of Taxes on revenue in 1994 and the Taxes (in $) of Taxes on goods and services in 1997?
Keep it short and to the point. 1.29e+09. What is the difference between the Taxes (in $) of Taxes on revenue in 1994 and the Taxes (in $) of Taxes on income in 1997?
Your answer should be compact. 2.17e+09. What is the difference between the Taxes (in $) in Taxes on exports in 1994 and the Taxes (in $) in Taxes on goods and services in 1997?
Offer a very short reply. -1.99e+09. What is the difference between the Taxes (in $) of Taxes on exports in 1994 and the Taxes (in $) of Taxes on income in 1997?
Make the answer very short. -1.10e+09. What is the difference between the Taxes (in $) of Taxes on goods and services in 1994 and the Taxes (in $) of Taxes on income in 1997?
Offer a very short reply. -1.13e+08. What is the difference between the Taxes (in $) in Taxes on revenue in 1994 and the Taxes (in $) in Taxes on exports in 1998?
Offer a terse response. 3.28e+09. What is the difference between the Taxes (in $) of Taxes on revenue in 1994 and the Taxes (in $) of Taxes on goods and services in 1998?
Make the answer very short. 9.83e+08. What is the difference between the Taxes (in $) of Taxes on revenue in 1994 and the Taxes (in $) of Taxes on income in 1998?
Your answer should be very brief. 2.00e+09. What is the difference between the Taxes (in $) of Taxes on exports in 1994 and the Taxes (in $) of Taxes on goods and services in 1998?
Ensure brevity in your answer.  -2.29e+09. What is the difference between the Taxes (in $) of Taxes on exports in 1994 and the Taxes (in $) of Taxes on income in 1998?
Provide a short and direct response. -1.28e+09. What is the difference between the Taxes (in $) of Taxes on goods and services in 1994 and the Taxes (in $) of Taxes on income in 1998?
Your answer should be compact. -2.89e+08. What is the difference between the Taxes (in $) of Taxes on revenue in 1994 and the Taxes (in $) of Taxes on exports in 1999?
Your answer should be very brief. 3.28e+09. What is the difference between the Taxes (in $) of Taxes on revenue in 1994 and the Taxes (in $) of Taxes on goods and services in 1999?
Provide a short and direct response. 6.31e+08. What is the difference between the Taxes (in $) in Taxes on revenue in 1994 and the Taxes (in $) in Taxes on income in 1999?
Keep it short and to the point. 1.90e+09. What is the difference between the Taxes (in $) of Taxes on exports in 1994 and the Taxes (in $) of Taxes on goods and services in 1999?
Provide a short and direct response. -2.64e+09. What is the difference between the Taxes (in $) of Taxes on exports in 1994 and the Taxes (in $) of Taxes on income in 1999?
Provide a short and direct response. -1.37e+09. What is the difference between the Taxes (in $) in Taxes on goods and services in 1994 and the Taxes (in $) in Taxes on income in 1999?
Provide a short and direct response. -3.87e+08. What is the difference between the Taxes (in $) of Taxes on revenue in 1994 and the Taxes (in $) of Taxes on exports in 2000?
Provide a short and direct response. 3.27e+09. What is the difference between the Taxes (in $) of Taxes on revenue in 1994 and the Taxes (in $) of Taxes on goods and services in 2000?
Your answer should be very brief. 3.80e+08. What is the difference between the Taxes (in $) in Taxes on revenue in 1994 and the Taxes (in $) in Taxes on income in 2000?
Offer a very short reply. 1.69e+09. What is the difference between the Taxes (in $) of Taxes on exports in 1994 and the Taxes (in $) of Taxes on goods and services in 2000?
Offer a very short reply. -2.89e+09. What is the difference between the Taxes (in $) of Taxes on exports in 1994 and the Taxes (in $) of Taxes on income in 2000?
Provide a short and direct response. -1.59e+09. What is the difference between the Taxes (in $) of Taxes on goods and services in 1994 and the Taxes (in $) of Taxes on income in 2000?
Make the answer very short. -6.00e+08. What is the difference between the Taxes (in $) of Taxes on revenue in 1995 and the Taxes (in $) of Taxes on exports in 1996?
Your response must be concise. 3.48e+09. What is the difference between the Taxes (in $) in Taxes on revenue in 1995 and the Taxes (in $) in Taxes on goods and services in 1996?
Keep it short and to the point. 2.31e+09. What is the difference between the Taxes (in $) in Taxes on revenue in 1995 and the Taxes (in $) in Taxes on income in 1996?
Your answer should be compact. 2.60e+09. What is the difference between the Taxes (in $) of Taxes on exports in 1995 and the Taxes (in $) of Taxes on goods and services in 1996?
Keep it short and to the point. -1.17e+09. What is the difference between the Taxes (in $) in Taxes on exports in 1995 and the Taxes (in $) in Taxes on income in 1996?
Give a very brief answer. -8.80e+08. What is the difference between the Taxes (in $) of Taxes on goods and services in 1995 and the Taxes (in $) of Taxes on income in 1996?
Your answer should be compact. 1.41e+08. What is the difference between the Taxes (in $) of Taxes on revenue in 1995 and the Taxes (in $) of Taxes on exports in 1997?
Offer a terse response. 3.48e+09. What is the difference between the Taxes (in $) of Taxes on revenue in 1995 and the Taxes (in $) of Taxes on goods and services in 1997?
Keep it short and to the point. 1.50e+09. What is the difference between the Taxes (in $) in Taxes on revenue in 1995 and the Taxes (in $) in Taxes on income in 1997?
Make the answer very short. 2.38e+09. What is the difference between the Taxes (in $) of Taxes on exports in 1995 and the Taxes (in $) of Taxes on goods and services in 1997?
Make the answer very short. -1.99e+09. What is the difference between the Taxes (in $) in Taxes on exports in 1995 and the Taxes (in $) in Taxes on income in 1997?
Make the answer very short. -1.10e+09. What is the difference between the Taxes (in $) in Taxes on goods and services in 1995 and the Taxes (in $) in Taxes on income in 1997?
Your answer should be very brief. -8.06e+07. What is the difference between the Taxes (in $) of Taxes on revenue in 1995 and the Taxes (in $) of Taxes on exports in 1998?
Your answer should be compact. 3.49e+09. What is the difference between the Taxes (in $) in Taxes on revenue in 1995 and the Taxes (in $) in Taxes on goods and services in 1998?
Offer a very short reply. 1.19e+09. What is the difference between the Taxes (in $) in Taxes on revenue in 1995 and the Taxes (in $) in Taxes on income in 1998?
Provide a short and direct response. 2.21e+09. What is the difference between the Taxes (in $) of Taxes on exports in 1995 and the Taxes (in $) of Taxes on goods and services in 1998?
Your response must be concise. -2.29e+09. What is the difference between the Taxes (in $) of Taxes on exports in 1995 and the Taxes (in $) of Taxes on income in 1998?
Your response must be concise. -1.28e+09. What is the difference between the Taxes (in $) of Taxes on goods and services in 1995 and the Taxes (in $) of Taxes on income in 1998?
Make the answer very short. -2.57e+08. What is the difference between the Taxes (in $) in Taxes on revenue in 1995 and the Taxes (in $) in Taxes on exports in 1999?
Your answer should be compact. 3.49e+09. What is the difference between the Taxes (in $) in Taxes on revenue in 1995 and the Taxes (in $) in Taxes on goods and services in 1999?
Provide a short and direct response. 8.40e+08. What is the difference between the Taxes (in $) in Taxes on revenue in 1995 and the Taxes (in $) in Taxes on income in 1999?
Your response must be concise. 2.11e+09. What is the difference between the Taxes (in $) of Taxes on exports in 1995 and the Taxes (in $) of Taxes on goods and services in 1999?
Your answer should be compact. -2.64e+09. What is the difference between the Taxes (in $) of Taxes on exports in 1995 and the Taxes (in $) of Taxes on income in 1999?
Offer a very short reply. -1.38e+09. What is the difference between the Taxes (in $) in Taxes on goods and services in 1995 and the Taxes (in $) in Taxes on income in 1999?
Offer a very short reply. -3.54e+08. What is the difference between the Taxes (in $) of Taxes on revenue in 1995 and the Taxes (in $) of Taxes on exports in 2000?
Give a very brief answer. 3.48e+09. What is the difference between the Taxes (in $) in Taxes on revenue in 1995 and the Taxes (in $) in Taxes on goods and services in 2000?
Your response must be concise. 5.90e+08. What is the difference between the Taxes (in $) of Taxes on revenue in 1995 and the Taxes (in $) of Taxes on income in 2000?
Your answer should be compact. 1.90e+09. What is the difference between the Taxes (in $) in Taxes on exports in 1995 and the Taxes (in $) in Taxes on goods and services in 2000?
Provide a short and direct response. -2.90e+09. What is the difference between the Taxes (in $) of Taxes on exports in 1995 and the Taxes (in $) of Taxes on income in 2000?
Your answer should be very brief. -1.59e+09. What is the difference between the Taxes (in $) of Taxes on goods and services in 1995 and the Taxes (in $) of Taxes on income in 2000?
Provide a succinct answer. -5.68e+08. What is the difference between the Taxes (in $) of Taxes on revenue in 1996 and the Taxes (in $) of Taxes on exports in 1997?
Offer a very short reply. 3.77e+09. What is the difference between the Taxes (in $) in Taxes on revenue in 1996 and the Taxes (in $) in Taxes on goods and services in 1997?
Offer a very short reply. 1.79e+09. What is the difference between the Taxes (in $) of Taxes on revenue in 1996 and the Taxes (in $) of Taxes on income in 1997?
Your answer should be compact. 2.67e+09. What is the difference between the Taxes (in $) in Taxes on exports in 1996 and the Taxes (in $) in Taxes on goods and services in 1997?
Your answer should be compact. -1.99e+09. What is the difference between the Taxes (in $) in Taxes on exports in 1996 and the Taxes (in $) in Taxes on income in 1997?
Ensure brevity in your answer.  -1.10e+09. What is the difference between the Taxes (in $) of Taxes on goods and services in 1996 and the Taxes (in $) of Taxes on income in 1997?
Your answer should be very brief. 6.84e+07. What is the difference between the Taxes (in $) of Taxes on revenue in 1996 and the Taxes (in $) of Taxes on exports in 1998?
Your answer should be compact. 3.78e+09. What is the difference between the Taxes (in $) of Taxes on revenue in 1996 and the Taxes (in $) of Taxes on goods and services in 1998?
Give a very brief answer. 1.48e+09. What is the difference between the Taxes (in $) in Taxes on revenue in 1996 and the Taxes (in $) in Taxes on income in 1998?
Provide a succinct answer. 2.50e+09. What is the difference between the Taxes (in $) in Taxes on exports in 1996 and the Taxes (in $) in Taxes on goods and services in 1998?
Your answer should be very brief. -2.29e+09. What is the difference between the Taxes (in $) in Taxes on exports in 1996 and the Taxes (in $) in Taxes on income in 1998?
Your answer should be compact. -1.28e+09. What is the difference between the Taxes (in $) of Taxes on goods and services in 1996 and the Taxes (in $) of Taxes on income in 1998?
Ensure brevity in your answer.  -1.08e+08. What is the difference between the Taxes (in $) of Taxes on revenue in 1996 and the Taxes (in $) of Taxes on exports in 1999?
Offer a terse response. 3.78e+09. What is the difference between the Taxes (in $) in Taxes on revenue in 1996 and the Taxes (in $) in Taxes on goods and services in 1999?
Make the answer very short. 1.13e+09. What is the difference between the Taxes (in $) in Taxes on revenue in 1996 and the Taxes (in $) in Taxes on income in 1999?
Offer a terse response. 2.40e+09. What is the difference between the Taxes (in $) of Taxes on exports in 1996 and the Taxes (in $) of Taxes on goods and services in 1999?
Provide a succinct answer. -2.64e+09. What is the difference between the Taxes (in $) in Taxes on exports in 1996 and the Taxes (in $) in Taxes on income in 1999?
Make the answer very short. -1.38e+09. What is the difference between the Taxes (in $) of Taxes on goods and services in 1996 and the Taxes (in $) of Taxes on income in 1999?
Make the answer very short. -2.05e+08. What is the difference between the Taxes (in $) of Taxes on revenue in 1996 and the Taxes (in $) of Taxes on exports in 2000?
Make the answer very short. 3.77e+09. What is the difference between the Taxes (in $) in Taxes on revenue in 1996 and the Taxes (in $) in Taxes on goods and services in 2000?
Ensure brevity in your answer.  8.79e+08. What is the difference between the Taxes (in $) in Taxes on revenue in 1996 and the Taxes (in $) in Taxes on income in 2000?
Your answer should be compact. 2.19e+09. What is the difference between the Taxes (in $) in Taxes on exports in 1996 and the Taxes (in $) in Taxes on goods and services in 2000?
Make the answer very short. -2.90e+09. What is the difference between the Taxes (in $) of Taxes on exports in 1996 and the Taxes (in $) of Taxes on income in 2000?
Ensure brevity in your answer.  -1.59e+09. What is the difference between the Taxes (in $) of Taxes on goods and services in 1996 and the Taxes (in $) of Taxes on income in 2000?
Give a very brief answer. -4.18e+08. What is the difference between the Taxes (in $) of Taxes on revenue in 1997 and the Taxes (in $) of Taxes on exports in 1998?
Ensure brevity in your answer.  4.22e+09. What is the difference between the Taxes (in $) in Taxes on revenue in 1997 and the Taxes (in $) in Taxes on goods and services in 1998?
Give a very brief answer. 1.93e+09. What is the difference between the Taxes (in $) of Taxes on revenue in 1997 and the Taxes (in $) of Taxes on income in 1998?
Provide a short and direct response. 2.95e+09. What is the difference between the Taxes (in $) of Taxes on exports in 1997 and the Taxes (in $) of Taxes on goods and services in 1998?
Your answer should be very brief. -2.29e+09. What is the difference between the Taxes (in $) of Taxes on exports in 1997 and the Taxes (in $) of Taxes on income in 1998?
Make the answer very short. -1.28e+09. What is the difference between the Taxes (in $) in Taxes on goods and services in 1997 and the Taxes (in $) in Taxes on income in 1998?
Your answer should be very brief. 7.10e+08. What is the difference between the Taxes (in $) in Taxes on revenue in 1997 and the Taxes (in $) in Taxes on exports in 1999?
Give a very brief answer. 4.22e+09. What is the difference between the Taxes (in $) in Taxes on revenue in 1997 and the Taxes (in $) in Taxes on goods and services in 1999?
Provide a succinct answer. 1.58e+09. What is the difference between the Taxes (in $) of Taxes on revenue in 1997 and the Taxes (in $) of Taxes on income in 1999?
Offer a very short reply. 2.85e+09. What is the difference between the Taxes (in $) in Taxes on exports in 1997 and the Taxes (in $) in Taxes on goods and services in 1999?
Your answer should be compact. -2.64e+09. What is the difference between the Taxes (in $) of Taxes on exports in 1997 and the Taxes (in $) of Taxes on income in 1999?
Give a very brief answer. -1.37e+09. What is the difference between the Taxes (in $) of Taxes on goods and services in 1997 and the Taxes (in $) of Taxes on income in 1999?
Offer a very short reply. 6.13e+08. What is the difference between the Taxes (in $) in Taxes on revenue in 1997 and the Taxes (in $) in Taxes on exports in 2000?
Make the answer very short. 4.22e+09. What is the difference between the Taxes (in $) in Taxes on revenue in 1997 and the Taxes (in $) in Taxes on goods and services in 2000?
Provide a short and direct response. 1.33e+09. What is the difference between the Taxes (in $) of Taxes on revenue in 1997 and the Taxes (in $) of Taxes on income in 2000?
Your answer should be very brief. 2.63e+09. What is the difference between the Taxes (in $) in Taxes on exports in 1997 and the Taxes (in $) in Taxes on goods and services in 2000?
Give a very brief answer. -2.89e+09. What is the difference between the Taxes (in $) in Taxes on exports in 1997 and the Taxes (in $) in Taxes on income in 2000?
Ensure brevity in your answer.  -1.59e+09. What is the difference between the Taxes (in $) of Taxes on goods and services in 1997 and the Taxes (in $) of Taxes on income in 2000?
Offer a very short reply. 4.00e+08. What is the difference between the Taxes (in $) of Taxes on revenue in 1998 and the Taxes (in $) of Taxes on exports in 1999?
Offer a very short reply. 4.76e+09. What is the difference between the Taxes (in $) in Taxes on revenue in 1998 and the Taxes (in $) in Taxes on goods and services in 1999?
Provide a short and direct response. 2.11e+09. What is the difference between the Taxes (in $) of Taxes on revenue in 1998 and the Taxes (in $) of Taxes on income in 1999?
Provide a succinct answer. 3.38e+09. What is the difference between the Taxes (in $) in Taxes on exports in 1998 and the Taxes (in $) in Taxes on goods and services in 1999?
Your answer should be very brief. -2.65e+09. What is the difference between the Taxes (in $) of Taxes on exports in 1998 and the Taxes (in $) of Taxes on income in 1999?
Your answer should be very brief. -1.38e+09. What is the difference between the Taxes (in $) in Taxes on goods and services in 1998 and the Taxes (in $) in Taxes on income in 1999?
Offer a very short reply. 9.17e+08. What is the difference between the Taxes (in $) in Taxes on revenue in 1998 and the Taxes (in $) in Taxes on exports in 2000?
Keep it short and to the point. 4.75e+09. What is the difference between the Taxes (in $) of Taxes on revenue in 1998 and the Taxes (in $) of Taxes on goods and services in 2000?
Make the answer very short. 1.86e+09. What is the difference between the Taxes (in $) in Taxes on revenue in 1998 and the Taxes (in $) in Taxes on income in 2000?
Offer a terse response. 3.17e+09. What is the difference between the Taxes (in $) in Taxes on exports in 1998 and the Taxes (in $) in Taxes on goods and services in 2000?
Ensure brevity in your answer.  -2.90e+09. What is the difference between the Taxes (in $) of Taxes on exports in 1998 and the Taxes (in $) of Taxes on income in 2000?
Offer a very short reply. -1.59e+09. What is the difference between the Taxes (in $) in Taxes on goods and services in 1998 and the Taxes (in $) in Taxes on income in 2000?
Give a very brief answer. 7.04e+08. What is the difference between the Taxes (in $) of Taxes on revenue in 1999 and the Taxes (in $) of Taxes on exports in 2000?
Provide a short and direct response. 5.20e+09. What is the difference between the Taxes (in $) in Taxes on revenue in 1999 and the Taxes (in $) in Taxes on goods and services in 2000?
Your response must be concise. 2.30e+09. What is the difference between the Taxes (in $) of Taxes on revenue in 1999 and the Taxes (in $) of Taxes on income in 2000?
Provide a succinct answer. 3.61e+09. What is the difference between the Taxes (in $) of Taxes on exports in 1999 and the Taxes (in $) of Taxes on goods and services in 2000?
Your answer should be very brief. -2.90e+09. What is the difference between the Taxes (in $) in Taxes on exports in 1999 and the Taxes (in $) in Taxes on income in 2000?
Make the answer very short. -1.59e+09. What is the difference between the Taxes (in $) in Taxes on goods and services in 1999 and the Taxes (in $) in Taxes on income in 2000?
Provide a short and direct response. 1.06e+09. What is the average Taxes (in $) of Taxes on revenue per year?
Ensure brevity in your answer.  4.04e+09. What is the average Taxes (in $) of Taxes on exports per year?
Ensure brevity in your answer.  8.81e+06. What is the average Taxes (in $) in Taxes on goods and services per year?
Your response must be concise. 1.65e+09. What is the average Taxes (in $) in Taxes on income per year?
Offer a terse response. 1.01e+09. In the year 1992, what is the difference between the Taxes (in $) of Taxes on revenue and Taxes (in $) of Taxes on exports?
Your response must be concise. 2.80e+09. In the year 1992, what is the difference between the Taxes (in $) of Taxes on revenue and Taxes (in $) of Taxes on goods and services?
Ensure brevity in your answer.  1.96e+09. In the year 1992, what is the difference between the Taxes (in $) in Taxes on revenue and Taxes (in $) in Taxes on income?
Provide a succinct answer. 2.25e+09. In the year 1992, what is the difference between the Taxes (in $) of Taxes on exports and Taxes (in $) of Taxes on goods and services?
Keep it short and to the point. -8.39e+08. In the year 1992, what is the difference between the Taxes (in $) in Taxes on exports and Taxes (in $) in Taxes on income?
Offer a terse response. -5.52e+08. In the year 1992, what is the difference between the Taxes (in $) in Taxes on goods and services and Taxes (in $) in Taxes on income?
Ensure brevity in your answer.  2.86e+08. In the year 1993, what is the difference between the Taxes (in $) in Taxes on revenue and Taxes (in $) in Taxes on exports?
Your answer should be very brief. 3.07e+09. In the year 1993, what is the difference between the Taxes (in $) in Taxes on revenue and Taxes (in $) in Taxes on goods and services?
Offer a very short reply. 2.17e+09. In the year 1993, what is the difference between the Taxes (in $) of Taxes on revenue and Taxes (in $) of Taxes on income?
Ensure brevity in your answer.  2.38e+09. In the year 1993, what is the difference between the Taxes (in $) of Taxes on exports and Taxes (in $) of Taxes on goods and services?
Keep it short and to the point. -9.04e+08. In the year 1993, what is the difference between the Taxes (in $) of Taxes on exports and Taxes (in $) of Taxes on income?
Provide a short and direct response. -6.89e+08. In the year 1993, what is the difference between the Taxes (in $) in Taxes on goods and services and Taxes (in $) in Taxes on income?
Offer a very short reply. 2.15e+08. In the year 1994, what is the difference between the Taxes (in $) of Taxes on revenue and Taxes (in $) of Taxes on exports?
Offer a very short reply. 3.27e+09. In the year 1994, what is the difference between the Taxes (in $) of Taxes on revenue and Taxes (in $) of Taxes on goods and services?
Your response must be concise. 2.29e+09. In the year 1994, what is the difference between the Taxes (in $) in Taxes on revenue and Taxes (in $) in Taxes on income?
Provide a succinct answer. 2.55e+09. In the year 1994, what is the difference between the Taxes (in $) in Taxes on exports and Taxes (in $) in Taxes on goods and services?
Make the answer very short. -9.87e+08. In the year 1994, what is the difference between the Taxes (in $) of Taxes on exports and Taxes (in $) of Taxes on income?
Ensure brevity in your answer.  -7.24e+08. In the year 1994, what is the difference between the Taxes (in $) of Taxes on goods and services and Taxes (in $) of Taxes on income?
Your answer should be very brief. 2.63e+08. In the year 1995, what is the difference between the Taxes (in $) in Taxes on revenue and Taxes (in $) in Taxes on exports?
Your response must be concise. 3.48e+09. In the year 1995, what is the difference between the Taxes (in $) of Taxes on revenue and Taxes (in $) of Taxes on goods and services?
Offer a terse response. 2.46e+09. In the year 1995, what is the difference between the Taxes (in $) of Taxes on revenue and Taxes (in $) of Taxes on income?
Your answer should be compact. 2.69e+09. In the year 1995, what is the difference between the Taxes (in $) of Taxes on exports and Taxes (in $) of Taxes on goods and services?
Provide a succinct answer. -1.02e+09. In the year 1995, what is the difference between the Taxes (in $) in Taxes on exports and Taxes (in $) in Taxes on income?
Your answer should be compact. -7.99e+08. In the year 1995, what is the difference between the Taxes (in $) of Taxes on goods and services and Taxes (in $) of Taxes on income?
Your answer should be compact. 2.22e+08. In the year 1996, what is the difference between the Taxes (in $) in Taxes on revenue and Taxes (in $) in Taxes on exports?
Keep it short and to the point. 3.77e+09. In the year 1996, what is the difference between the Taxes (in $) of Taxes on revenue and Taxes (in $) of Taxes on goods and services?
Make the answer very short. 2.60e+09. In the year 1996, what is the difference between the Taxes (in $) in Taxes on revenue and Taxes (in $) in Taxes on income?
Your answer should be compact. 2.89e+09. In the year 1996, what is the difference between the Taxes (in $) in Taxes on exports and Taxes (in $) in Taxes on goods and services?
Give a very brief answer. -1.17e+09. In the year 1996, what is the difference between the Taxes (in $) in Taxes on exports and Taxes (in $) in Taxes on income?
Offer a very short reply. -8.80e+08. In the year 1996, what is the difference between the Taxes (in $) of Taxes on goods and services and Taxes (in $) of Taxes on income?
Provide a succinct answer. 2.90e+08. In the year 1997, what is the difference between the Taxes (in $) in Taxes on revenue and Taxes (in $) in Taxes on exports?
Your answer should be very brief. 4.22e+09. In the year 1997, what is the difference between the Taxes (in $) of Taxes on revenue and Taxes (in $) of Taxes on goods and services?
Your response must be concise. 2.23e+09. In the year 1997, what is the difference between the Taxes (in $) in Taxes on revenue and Taxes (in $) in Taxes on income?
Provide a succinct answer. 3.12e+09. In the year 1997, what is the difference between the Taxes (in $) of Taxes on exports and Taxes (in $) of Taxes on goods and services?
Give a very brief answer. -1.99e+09. In the year 1997, what is the difference between the Taxes (in $) in Taxes on exports and Taxes (in $) in Taxes on income?
Provide a succinct answer. -1.10e+09. In the year 1997, what is the difference between the Taxes (in $) in Taxes on goods and services and Taxes (in $) in Taxes on income?
Keep it short and to the point. 8.86e+08. In the year 1998, what is the difference between the Taxes (in $) of Taxes on revenue and Taxes (in $) of Taxes on exports?
Provide a short and direct response. 4.76e+09. In the year 1998, what is the difference between the Taxes (in $) of Taxes on revenue and Taxes (in $) of Taxes on goods and services?
Give a very brief answer. 2.46e+09. In the year 1998, what is the difference between the Taxes (in $) of Taxes on revenue and Taxes (in $) of Taxes on income?
Give a very brief answer. 3.48e+09. In the year 1998, what is the difference between the Taxes (in $) of Taxes on exports and Taxes (in $) of Taxes on goods and services?
Provide a short and direct response. -2.29e+09. In the year 1998, what is the difference between the Taxes (in $) of Taxes on exports and Taxes (in $) of Taxes on income?
Make the answer very short. -1.28e+09. In the year 1998, what is the difference between the Taxes (in $) of Taxes on goods and services and Taxes (in $) of Taxes on income?
Offer a very short reply. 1.01e+09. In the year 1999, what is the difference between the Taxes (in $) in Taxes on revenue and Taxes (in $) in Taxes on exports?
Provide a short and direct response. 5.20e+09. In the year 1999, what is the difference between the Taxes (in $) of Taxes on revenue and Taxes (in $) of Taxes on goods and services?
Provide a succinct answer. 2.55e+09. In the year 1999, what is the difference between the Taxes (in $) in Taxes on revenue and Taxes (in $) in Taxes on income?
Give a very brief answer. 3.82e+09. In the year 1999, what is the difference between the Taxes (in $) in Taxes on exports and Taxes (in $) in Taxes on goods and services?
Offer a very short reply. -2.65e+09. In the year 1999, what is the difference between the Taxes (in $) in Taxes on exports and Taxes (in $) in Taxes on income?
Provide a succinct answer. -1.38e+09. In the year 1999, what is the difference between the Taxes (in $) in Taxes on goods and services and Taxes (in $) in Taxes on income?
Your answer should be compact. 1.27e+09. In the year 2000, what is the difference between the Taxes (in $) of Taxes on revenue and Taxes (in $) of Taxes on exports?
Your answer should be compact. 5.67e+09. In the year 2000, what is the difference between the Taxes (in $) of Taxes on revenue and Taxes (in $) of Taxes on goods and services?
Keep it short and to the point. 2.77e+09. In the year 2000, what is the difference between the Taxes (in $) in Taxes on revenue and Taxes (in $) in Taxes on income?
Keep it short and to the point. 4.08e+09. In the year 2000, what is the difference between the Taxes (in $) of Taxes on exports and Taxes (in $) of Taxes on goods and services?
Offer a terse response. -2.89e+09. In the year 2000, what is the difference between the Taxes (in $) in Taxes on exports and Taxes (in $) in Taxes on income?
Your response must be concise. -1.59e+09. In the year 2000, what is the difference between the Taxes (in $) of Taxes on goods and services and Taxes (in $) of Taxes on income?
Provide a succinct answer. 1.31e+09. What is the ratio of the Taxes (in $) of Taxes on revenue in 1992 to that in 1993?
Keep it short and to the point. 0.91. What is the ratio of the Taxes (in $) in Taxes on goods and services in 1992 to that in 1993?
Provide a succinct answer. 0.93. What is the ratio of the Taxes (in $) in Taxes on income in 1992 to that in 1993?
Provide a succinct answer. 0.8. What is the ratio of the Taxes (in $) in Taxes on revenue in 1992 to that in 1994?
Keep it short and to the point. 0.86. What is the ratio of the Taxes (in $) of Taxes on exports in 1992 to that in 1994?
Make the answer very short. 0.94. What is the ratio of the Taxes (in $) of Taxes on goods and services in 1992 to that in 1994?
Make the answer very short. 0.85. What is the ratio of the Taxes (in $) of Taxes on income in 1992 to that in 1994?
Make the answer very short. 0.77. What is the ratio of the Taxes (in $) in Taxes on revenue in 1992 to that in 1995?
Your answer should be very brief. 0.8. What is the ratio of the Taxes (in $) of Taxes on exports in 1992 to that in 1995?
Provide a short and direct response. 1.06. What is the ratio of the Taxes (in $) in Taxes on goods and services in 1992 to that in 1995?
Keep it short and to the point. 0.82. What is the ratio of the Taxes (in $) in Taxes on income in 1992 to that in 1995?
Your response must be concise. 0.7. What is the ratio of the Taxes (in $) in Taxes on revenue in 1992 to that in 1996?
Ensure brevity in your answer.  0.74. What is the ratio of the Taxes (in $) in Taxes on exports in 1992 to that in 1996?
Your answer should be compact. 1.07. What is the ratio of the Taxes (in $) of Taxes on goods and services in 1992 to that in 1996?
Give a very brief answer. 0.72. What is the ratio of the Taxes (in $) of Taxes on income in 1992 to that in 1996?
Keep it short and to the point. 0.63. What is the ratio of the Taxes (in $) in Taxes on revenue in 1992 to that in 1997?
Keep it short and to the point. 0.66. What is the ratio of the Taxes (in $) in Taxes on exports in 1992 to that in 1997?
Make the answer very short. 0.89. What is the ratio of the Taxes (in $) in Taxes on goods and services in 1992 to that in 1997?
Make the answer very short. 0.42. What is the ratio of the Taxes (in $) of Taxes on income in 1992 to that in 1997?
Your answer should be compact. 0.51. What is the ratio of the Taxes (in $) of Taxes on revenue in 1992 to that in 1998?
Give a very brief answer. 0.59. What is the ratio of the Taxes (in $) in Taxes on exports in 1992 to that in 1998?
Keep it short and to the point. 1.36. What is the ratio of the Taxes (in $) in Taxes on goods and services in 1992 to that in 1998?
Your answer should be compact. 0.37. What is the ratio of the Taxes (in $) in Taxes on income in 1992 to that in 1998?
Your answer should be very brief. 0.44. What is the ratio of the Taxes (in $) in Taxes on revenue in 1992 to that in 1999?
Provide a succinct answer. 0.54. What is the ratio of the Taxes (in $) of Taxes on exports in 1992 to that in 1999?
Give a very brief answer. 1.47. What is the ratio of the Taxes (in $) in Taxes on goods and services in 1992 to that in 1999?
Your answer should be compact. 0.32. What is the ratio of the Taxes (in $) in Taxes on income in 1992 to that in 1999?
Ensure brevity in your answer.  0.41. What is the ratio of the Taxes (in $) in Taxes on revenue in 1992 to that in 2000?
Ensure brevity in your answer.  0.49. What is the ratio of the Taxes (in $) of Taxes on exports in 1992 to that in 2000?
Give a very brief answer. 0.81. What is the ratio of the Taxes (in $) in Taxes on goods and services in 1992 to that in 2000?
Your response must be concise. 0.29. What is the ratio of the Taxes (in $) of Taxes on income in 1992 to that in 2000?
Offer a terse response. 0.35. What is the ratio of the Taxes (in $) of Taxes on revenue in 1993 to that in 1994?
Your response must be concise. 0.94. What is the ratio of the Taxes (in $) of Taxes on exports in 1993 to that in 1994?
Keep it short and to the point. 0.94. What is the ratio of the Taxes (in $) of Taxes on goods and services in 1993 to that in 1994?
Give a very brief answer. 0.92. What is the ratio of the Taxes (in $) of Taxes on income in 1993 to that in 1994?
Offer a terse response. 0.95. What is the ratio of the Taxes (in $) in Taxes on revenue in 1993 to that in 1995?
Provide a succinct answer. 0.88. What is the ratio of the Taxes (in $) in Taxes on exports in 1993 to that in 1995?
Provide a short and direct response. 1.06. What is the ratio of the Taxes (in $) of Taxes on goods and services in 1993 to that in 1995?
Ensure brevity in your answer.  0.89. What is the ratio of the Taxes (in $) of Taxes on income in 1993 to that in 1995?
Keep it short and to the point. 0.86. What is the ratio of the Taxes (in $) of Taxes on revenue in 1993 to that in 1996?
Your answer should be very brief. 0.81. What is the ratio of the Taxes (in $) of Taxes on exports in 1993 to that in 1996?
Ensure brevity in your answer.  1.07. What is the ratio of the Taxes (in $) of Taxes on goods and services in 1993 to that in 1996?
Your answer should be very brief. 0.78. What is the ratio of the Taxes (in $) of Taxes on income in 1993 to that in 1996?
Your answer should be very brief. 0.79. What is the ratio of the Taxes (in $) in Taxes on revenue in 1993 to that in 1997?
Your answer should be very brief. 0.73. What is the ratio of the Taxes (in $) in Taxes on exports in 1993 to that in 1997?
Your answer should be very brief. 0.89. What is the ratio of the Taxes (in $) of Taxes on goods and services in 1993 to that in 1997?
Keep it short and to the point. 0.46. What is the ratio of the Taxes (in $) of Taxes on income in 1993 to that in 1997?
Your response must be concise. 0.63. What is the ratio of the Taxes (in $) of Taxes on revenue in 1993 to that in 1998?
Offer a terse response. 0.65. What is the ratio of the Taxes (in $) of Taxes on exports in 1993 to that in 1998?
Offer a very short reply. 1.36. What is the ratio of the Taxes (in $) in Taxes on goods and services in 1993 to that in 1998?
Offer a terse response. 0.4. What is the ratio of the Taxes (in $) in Taxes on income in 1993 to that in 1998?
Provide a short and direct response. 0.54. What is the ratio of the Taxes (in $) of Taxes on revenue in 1993 to that in 1999?
Provide a short and direct response. 0.59. What is the ratio of the Taxes (in $) in Taxes on exports in 1993 to that in 1999?
Provide a short and direct response. 1.47. What is the ratio of the Taxes (in $) of Taxes on goods and services in 1993 to that in 1999?
Provide a short and direct response. 0.34. What is the ratio of the Taxes (in $) of Taxes on income in 1993 to that in 1999?
Offer a very short reply. 0.5. What is the ratio of the Taxes (in $) in Taxes on revenue in 1993 to that in 2000?
Your response must be concise. 0.54. What is the ratio of the Taxes (in $) in Taxes on exports in 1993 to that in 2000?
Your response must be concise. 0.81. What is the ratio of the Taxes (in $) of Taxes on goods and services in 1993 to that in 2000?
Offer a very short reply. 0.31. What is the ratio of the Taxes (in $) in Taxes on income in 1993 to that in 2000?
Keep it short and to the point. 0.44. What is the ratio of the Taxes (in $) in Taxes on exports in 1994 to that in 1995?
Make the answer very short. 1.13. What is the ratio of the Taxes (in $) of Taxes on goods and services in 1994 to that in 1995?
Your response must be concise. 0.97. What is the ratio of the Taxes (in $) of Taxes on income in 1994 to that in 1995?
Offer a terse response. 0.91. What is the ratio of the Taxes (in $) of Taxes on revenue in 1994 to that in 1996?
Provide a short and direct response. 0.87. What is the ratio of the Taxes (in $) in Taxes on exports in 1994 to that in 1996?
Ensure brevity in your answer.  1.14. What is the ratio of the Taxes (in $) in Taxes on goods and services in 1994 to that in 1996?
Your response must be concise. 0.85. What is the ratio of the Taxes (in $) of Taxes on income in 1994 to that in 1996?
Offer a terse response. 0.83. What is the ratio of the Taxes (in $) of Taxes on revenue in 1994 to that in 1997?
Provide a succinct answer. 0.78. What is the ratio of the Taxes (in $) of Taxes on exports in 1994 to that in 1997?
Provide a succinct answer. 0.95. What is the ratio of the Taxes (in $) in Taxes on goods and services in 1994 to that in 1997?
Your answer should be compact. 0.5. What is the ratio of the Taxes (in $) of Taxes on income in 1994 to that in 1997?
Your response must be concise. 0.66. What is the ratio of the Taxes (in $) of Taxes on revenue in 1994 to that in 1998?
Provide a succinct answer. 0.69. What is the ratio of the Taxes (in $) in Taxes on exports in 1994 to that in 1998?
Make the answer very short. 1.45. What is the ratio of the Taxes (in $) of Taxes on goods and services in 1994 to that in 1998?
Your response must be concise. 0.43. What is the ratio of the Taxes (in $) of Taxes on income in 1994 to that in 1998?
Make the answer very short. 0.57. What is the ratio of the Taxes (in $) of Taxes on revenue in 1994 to that in 1999?
Your answer should be very brief. 0.63. What is the ratio of the Taxes (in $) of Taxes on exports in 1994 to that in 1999?
Keep it short and to the point. 1.56. What is the ratio of the Taxes (in $) in Taxes on goods and services in 1994 to that in 1999?
Keep it short and to the point. 0.38. What is the ratio of the Taxes (in $) of Taxes on income in 1994 to that in 1999?
Make the answer very short. 0.53. What is the ratio of the Taxes (in $) of Taxes on revenue in 1994 to that in 2000?
Make the answer very short. 0.58. What is the ratio of the Taxes (in $) in Taxes on exports in 1994 to that in 2000?
Provide a succinct answer. 0.87. What is the ratio of the Taxes (in $) of Taxes on goods and services in 1994 to that in 2000?
Ensure brevity in your answer.  0.34. What is the ratio of the Taxes (in $) of Taxes on income in 1994 to that in 2000?
Your answer should be very brief. 0.46. What is the ratio of the Taxes (in $) in Taxes on revenue in 1995 to that in 1996?
Ensure brevity in your answer.  0.92. What is the ratio of the Taxes (in $) in Taxes on exports in 1995 to that in 1996?
Make the answer very short. 1.01. What is the ratio of the Taxes (in $) in Taxes on goods and services in 1995 to that in 1996?
Offer a terse response. 0.87. What is the ratio of the Taxes (in $) of Taxes on income in 1995 to that in 1996?
Make the answer very short. 0.91. What is the ratio of the Taxes (in $) in Taxes on revenue in 1995 to that in 1997?
Offer a very short reply. 0.83. What is the ratio of the Taxes (in $) in Taxes on exports in 1995 to that in 1997?
Give a very brief answer. 0.84. What is the ratio of the Taxes (in $) of Taxes on goods and services in 1995 to that in 1997?
Your answer should be compact. 0.52. What is the ratio of the Taxes (in $) of Taxes on income in 1995 to that in 1997?
Offer a very short reply. 0.73. What is the ratio of the Taxes (in $) in Taxes on revenue in 1995 to that in 1998?
Ensure brevity in your answer.  0.73. What is the ratio of the Taxes (in $) of Taxes on exports in 1995 to that in 1998?
Your response must be concise. 1.28. What is the ratio of the Taxes (in $) in Taxes on goods and services in 1995 to that in 1998?
Your answer should be very brief. 0.45. What is the ratio of the Taxes (in $) in Taxes on income in 1995 to that in 1998?
Give a very brief answer. 0.63. What is the ratio of the Taxes (in $) of Taxes on revenue in 1995 to that in 1999?
Give a very brief answer. 0.67. What is the ratio of the Taxes (in $) in Taxes on exports in 1995 to that in 1999?
Offer a terse response. 1.39. What is the ratio of the Taxes (in $) in Taxes on goods and services in 1995 to that in 1999?
Provide a succinct answer. 0.39. What is the ratio of the Taxes (in $) of Taxes on income in 1995 to that in 1999?
Offer a very short reply. 0.58. What is the ratio of the Taxes (in $) of Taxes on revenue in 1995 to that in 2000?
Make the answer very short. 0.62. What is the ratio of the Taxes (in $) of Taxes on exports in 1995 to that in 2000?
Ensure brevity in your answer.  0.77. What is the ratio of the Taxes (in $) of Taxes on goods and services in 1995 to that in 2000?
Offer a terse response. 0.35. What is the ratio of the Taxes (in $) of Taxes on income in 1995 to that in 2000?
Your answer should be very brief. 0.51. What is the ratio of the Taxes (in $) of Taxes on revenue in 1996 to that in 1997?
Your answer should be compact. 0.89. What is the ratio of the Taxes (in $) in Taxes on exports in 1996 to that in 1997?
Make the answer very short. 0.83. What is the ratio of the Taxes (in $) in Taxes on goods and services in 1996 to that in 1997?
Provide a short and direct response. 0.59. What is the ratio of the Taxes (in $) of Taxes on income in 1996 to that in 1997?
Provide a succinct answer. 0.8. What is the ratio of the Taxes (in $) of Taxes on revenue in 1996 to that in 1998?
Your response must be concise. 0.79. What is the ratio of the Taxes (in $) of Taxes on exports in 1996 to that in 1998?
Your answer should be compact. 1.27. What is the ratio of the Taxes (in $) in Taxes on goods and services in 1996 to that in 1998?
Offer a very short reply. 0.51. What is the ratio of the Taxes (in $) in Taxes on income in 1996 to that in 1998?
Offer a very short reply. 0.69. What is the ratio of the Taxes (in $) in Taxes on revenue in 1996 to that in 1999?
Your answer should be compact. 0.73. What is the ratio of the Taxes (in $) of Taxes on exports in 1996 to that in 1999?
Keep it short and to the point. 1.37. What is the ratio of the Taxes (in $) of Taxes on goods and services in 1996 to that in 1999?
Make the answer very short. 0.44. What is the ratio of the Taxes (in $) of Taxes on income in 1996 to that in 1999?
Offer a very short reply. 0.64. What is the ratio of the Taxes (in $) in Taxes on revenue in 1996 to that in 2000?
Keep it short and to the point. 0.67. What is the ratio of the Taxes (in $) of Taxes on exports in 1996 to that in 2000?
Ensure brevity in your answer.  0.76. What is the ratio of the Taxes (in $) of Taxes on goods and services in 1996 to that in 2000?
Your response must be concise. 0.41. What is the ratio of the Taxes (in $) in Taxes on income in 1996 to that in 2000?
Provide a succinct answer. 0.56. What is the ratio of the Taxes (in $) in Taxes on revenue in 1997 to that in 1998?
Make the answer very short. 0.89. What is the ratio of the Taxes (in $) of Taxes on exports in 1997 to that in 1998?
Your response must be concise. 1.52. What is the ratio of the Taxes (in $) in Taxes on goods and services in 1997 to that in 1998?
Keep it short and to the point. 0.87. What is the ratio of the Taxes (in $) in Taxes on income in 1997 to that in 1998?
Your answer should be compact. 0.86. What is the ratio of the Taxes (in $) of Taxes on revenue in 1997 to that in 1999?
Ensure brevity in your answer.  0.81. What is the ratio of the Taxes (in $) of Taxes on exports in 1997 to that in 1999?
Keep it short and to the point. 1.65. What is the ratio of the Taxes (in $) of Taxes on goods and services in 1997 to that in 1999?
Offer a very short reply. 0.75. What is the ratio of the Taxes (in $) of Taxes on income in 1997 to that in 1999?
Your answer should be very brief. 0.8. What is the ratio of the Taxes (in $) in Taxes on revenue in 1997 to that in 2000?
Make the answer very short. 0.75. What is the ratio of the Taxes (in $) in Taxes on exports in 1997 to that in 2000?
Offer a very short reply. 0.91. What is the ratio of the Taxes (in $) in Taxes on goods and services in 1997 to that in 2000?
Ensure brevity in your answer.  0.69. What is the ratio of the Taxes (in $) in Taxes on income in 1997 to that in 2000?
Your answer should be very brief. 0.7. What is the ratio of the Taxes (in $) of Taxes on revenue in 1998 to that in 1999?
Make the answer very short. 0.91. What is the ratio of the Taxes (in $) of Taxes on exports in 1998 to that in 1999?
Offer a terse response. 1.08. What is the ratio of the Taxes (in $) of Taxes on goods and services in 1998 to that in 1999?
Provide a succinct answer. 0.87. What is the ratio of the Taxes (in $) of Taxes on income in 1998 to that in 1999?
Ensure brevity in your answer.  0.93. What is the ratio of the Taxes (in $) of Taxes on revenue in 1998 to that in 2000?
Ensure brevity in your answer.  0.84. What is the ratio of the Taxes (in $) of Taxes on exports in 1998 to that in 2000?
Provide a succinct answer. 0.6. What is the ratio of the Taxes (in $) of Taxes on goods and services in 1998 to that in 2000?
Your answer should be very brief. 0.79. What is the ratio of the Taxes (in $) of Taxes on income in 1998 to that in 2000?
Ensure brevity in your answer.  0.81. What is the ratio of the Taxes (in $) in Taxes on revenue in 1999 to that in 2000?
Offer a very short reply. 0.92. What is the ratio of the Taxes (in $) in Taxes on exports in 1999 to that in 2000?
Your response must be concise. 0.55. What is the ratio of the Taxes (in $) in Taxes on goods and services in 1999 to that in 2000?
Ensure brevity in your answer.  0.91. What is the ratio of the Taxes (in $) in Taxes on income in 1999 to that in 2000?
Make the answer very short. 0.87. What is the difference between the highest and the second highest Taxes (in $) of Taxes on revenue?
Give a very brief answer. 4.72e+08. What is the difference between the highest and the second highest Taxes (in $) of Taxes on goods and services?
Make the answer very short. 2.51e+08. What is the difference between the highest and the second highest Taxes (in $) of Taxes on income?
Your answer should be compact. 2.13e+08. What is the difference between the highest and the lowest Taxes (in $) of Taxes on revenue?
Make the answer very short. 2.87e+09. What is the difference between the highest and the lowest Taxes (in $) in Taxes on goods and services?
Make the answer very short. 2.06e+09. What is the difference between the highest and the lowest Taxes (in $) in Taxes on income?
Offer a very short reply. 1.04e+09. 